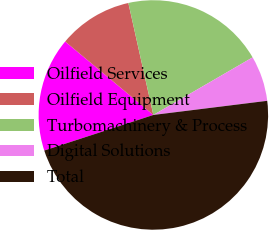Convert chart to OTSL. <chart><loc_0><loc_0><loc_500><loc_500><pie_chart><fcel>Oilfield Services<fcel>Oilfield Equipment<fcel>Turbomachinery & Process<fcel>Digital Solutions<fcel>Total<nl><fcel>16.07%<fcel>10.45%<fcel>20.13%<fcel>6.4%<fcel>46.95%<nl></chart> 